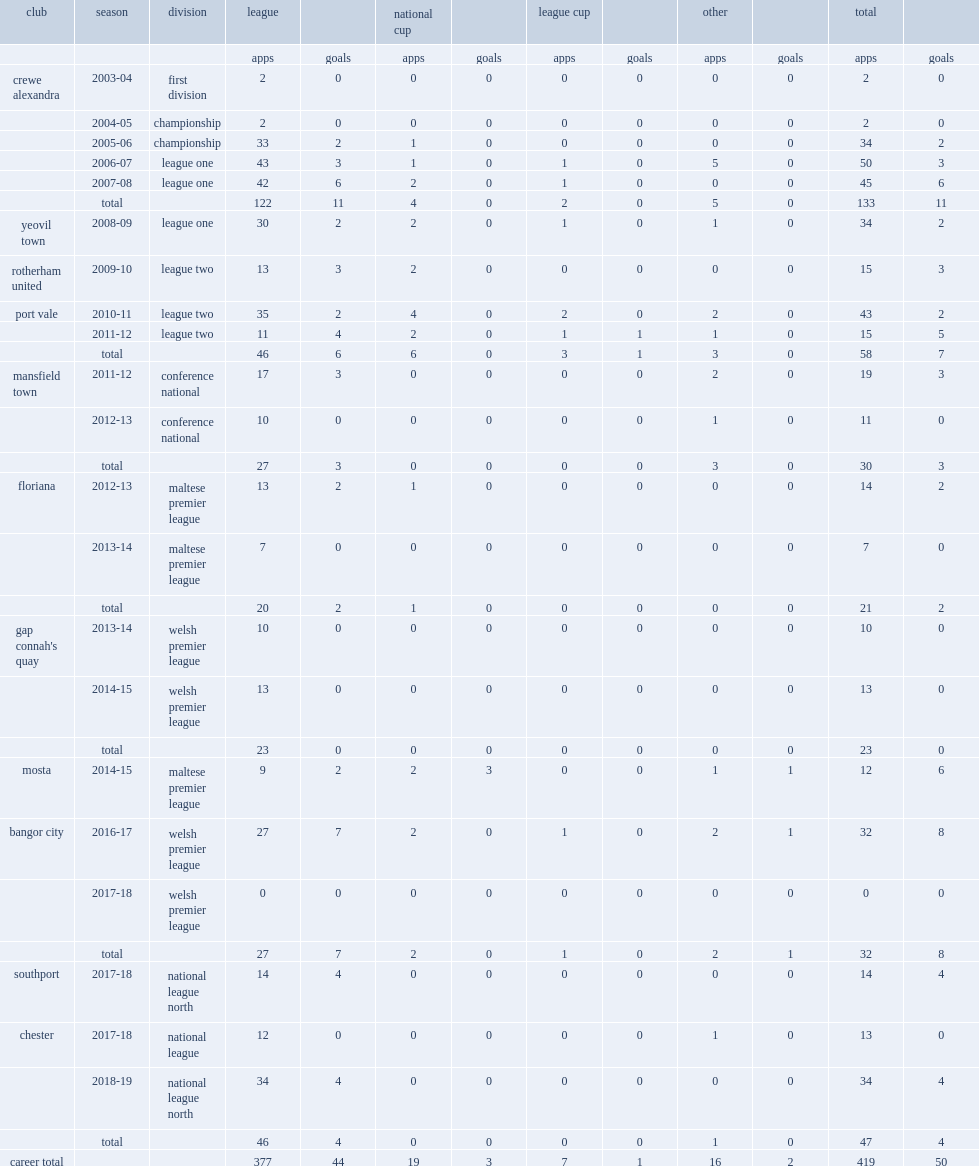Gary roberts started his career with crewe alexandra in 2003, how many league and cup appearances did he make over the next five years? 133.0. 